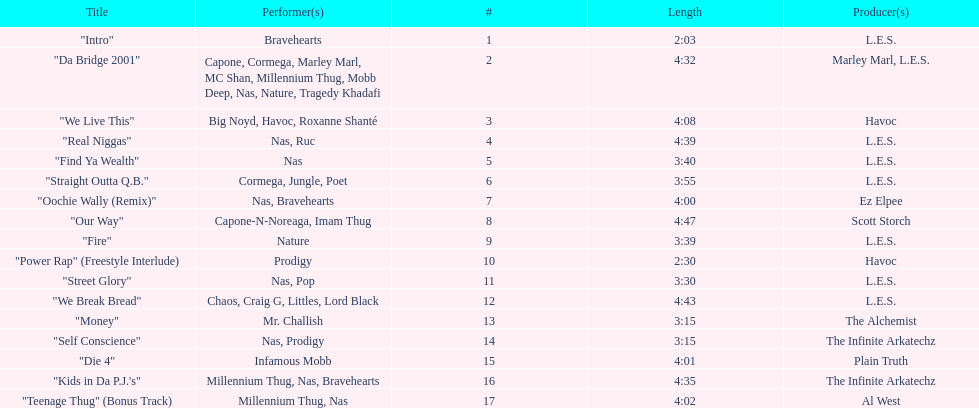What is the name of the last song on the album? "Teenage Thug" (Bonus Track). 